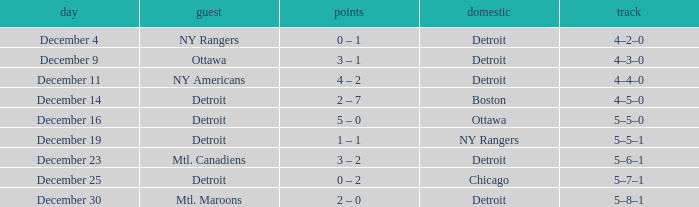What score has mtl. maroons as the visitor? 2 – 0. 